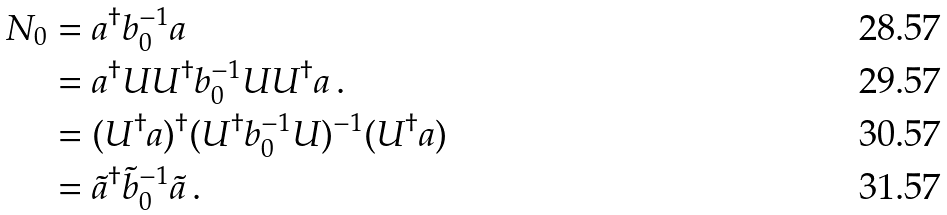Convert formula to latex. <formula><loc_0><loc_0><loc_500><loc_500>N _ { 0 } & = a ^ { \dagger } b _ { 0 } ^ { - 1 } a \\ & = a ^ { \dagger } U U ^ { \dagger } b _ { 0 } ^ { - 1 } U U ^ { \dagger } a \, . \\ & = ( U ^ { \dagger } a ) ^ { \dagger } ( U ^ { \dagger } b _ { 0 } ^ { - 1 } U ) ^ { - 1 } ( U ^ { \dagger } a ) \\ & = \tilde { a } ^ { \dagger } \tilde { b } _ { 0 } ^ { - 1 } \tilde { a } \, .</formula> 